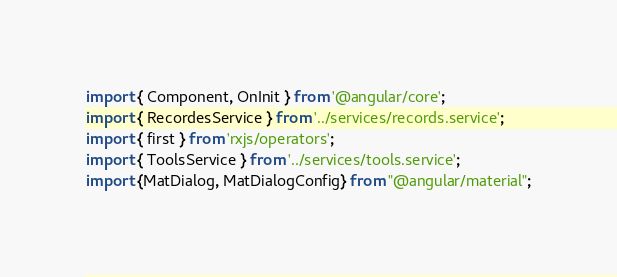<code> <loc_0><loc_0><loc_500><loc_500><_TypeScript_>import { Component, OnInit } from '@angular/core';
import { RecordesService } from '../services/records.service';
import { first } from 'rxjs/operators';
import { ToolsService } from '../services/tools.service';
import {MatDialog, MatDialogConfig} from "@angular/material";</code> 